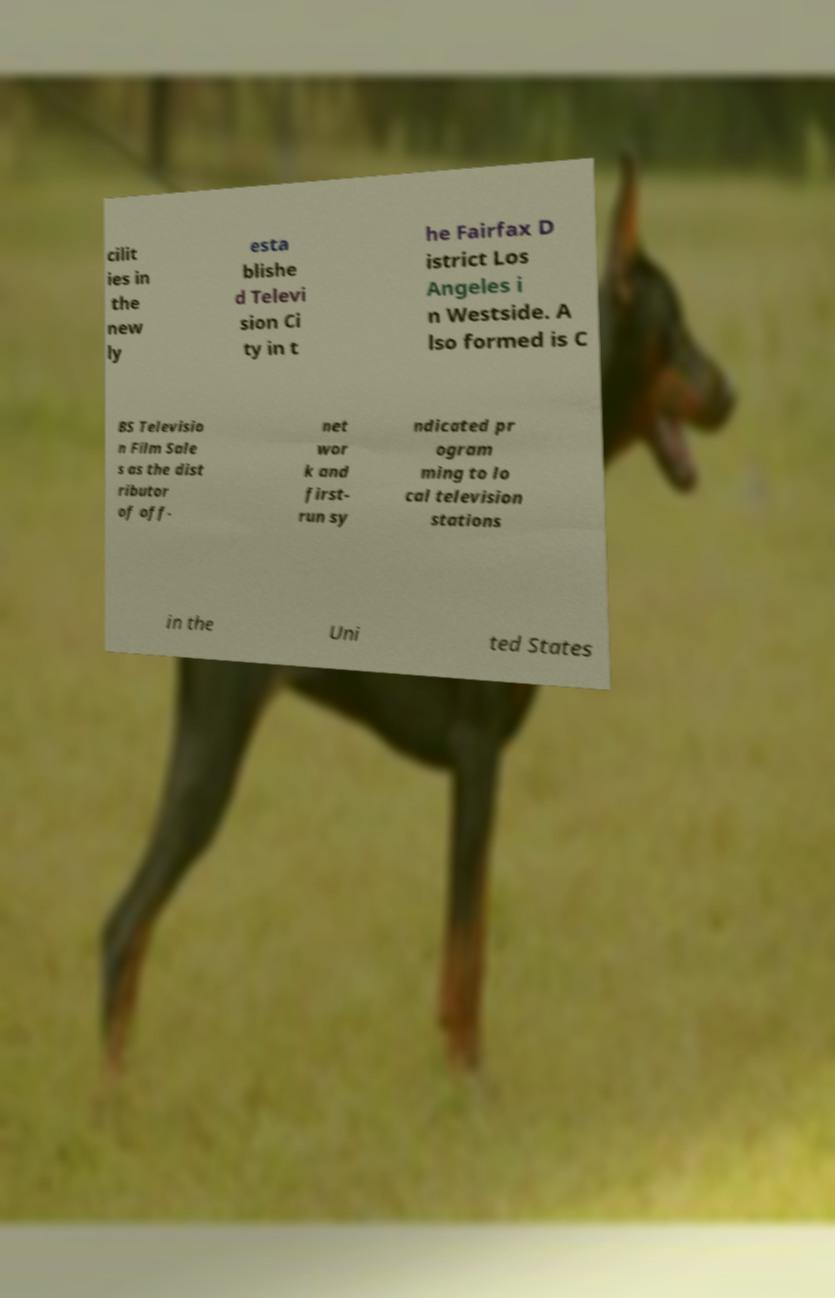There's text embedded in this image that I need extracted. Can you transcribe it verbatim? cilit ies in the new ly esta blishe d Televi sion Ci ty in t he Fairfax D istrict Los Angeles i n Westside. A lso formed is C BS Televisio n Film Sale s as the dist ributor of off- net wor k and first- run sy ndicated pr ogram ming to lo cal television stations in the Uni ted States 